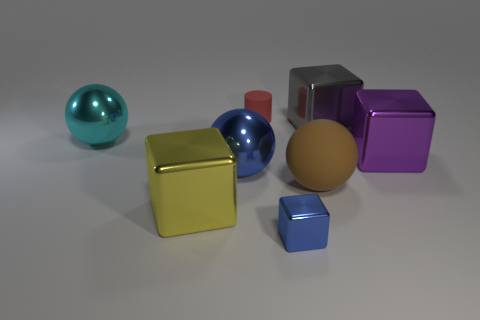Add 1 purple cubes. How many objects exist? 9 Subtract all tiny blue metal cubes. How many cubes are left? 3 Subtract all blue blocks. How many blocks are left? 3 Subtract all balls. How many objects are left? 5 Subtract 2 cubes. How many cubes are left? 2 Add 6 big yellow metallic cubes. How many big yellow metallic cubes are left? 7 Add 8 big gray matte cylinders. How many big gray matte cylinders exist? 8 Subtract 1 red cylinders. How many objects are left? 7 Subtract all red cubes. Subtract all blue balls. How many cubes are left? 4 Subtract all cyan spheres. How many yellow cubes are left? 1 